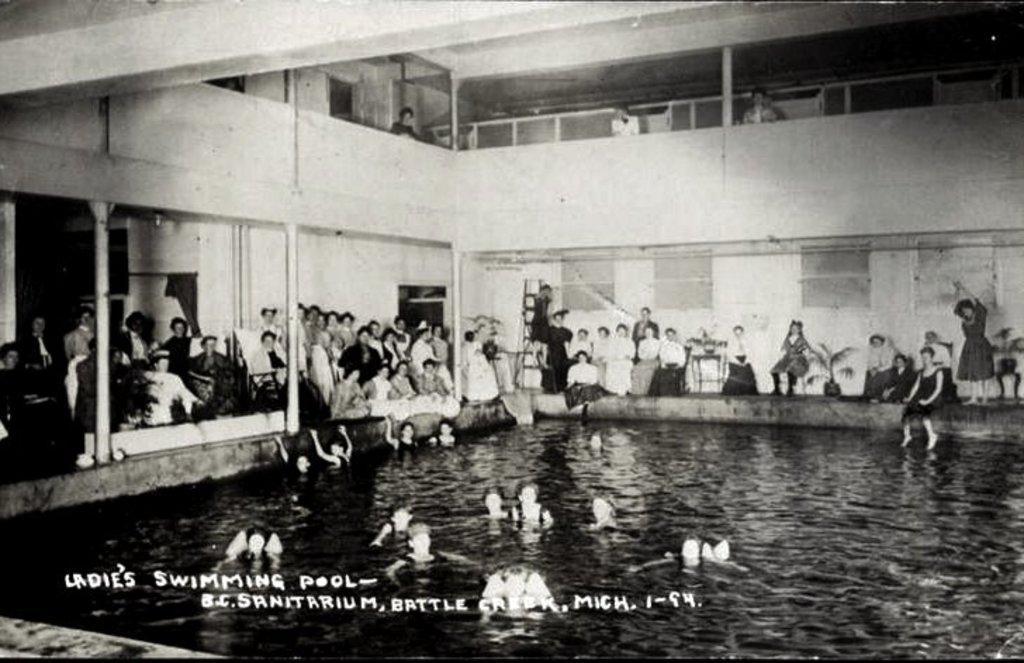Can you describe this image briefly? In this image I can see few people are in the water. To the side of the water I can see the group of people. Few people are standing and few of them are sitting. In the background there is a building and the railing. I can see something is written on the image. And this is a black and white image. 